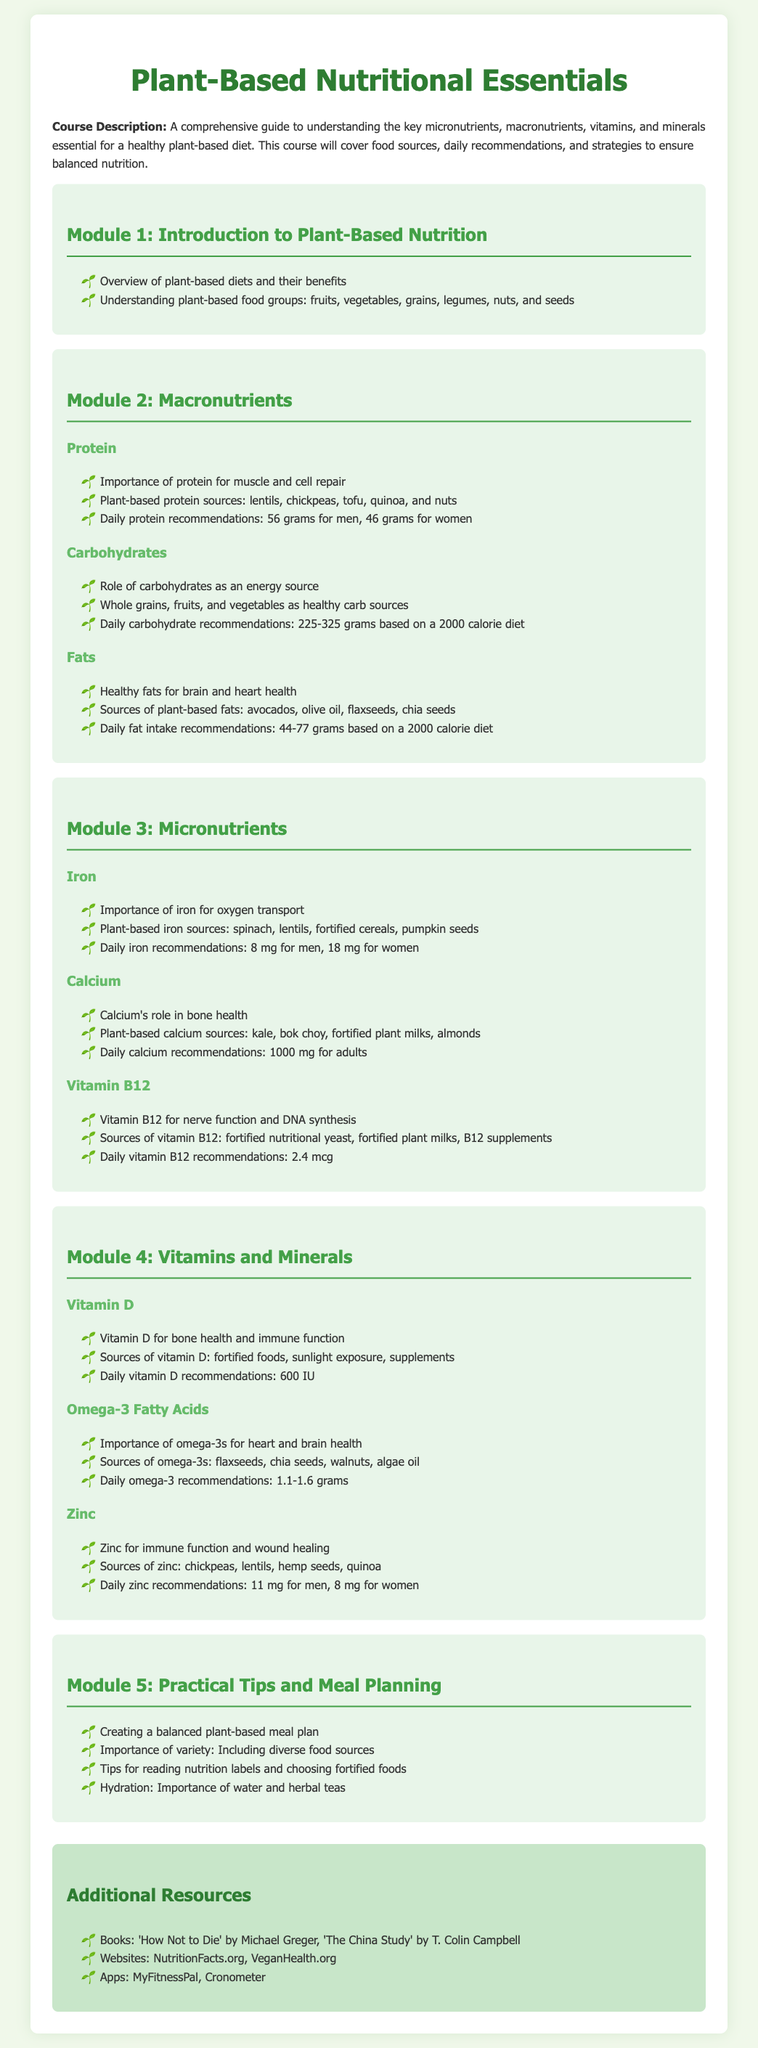What is the title of the course? The title of the course is mentioned at the top of the document.
Answer: Plant-Based Nutritional Essentials How many modules are there? The document lists the modules underlined by titles in the syllabus content.
Answer: Five What is the daily protein recommendation for men? The daily protein recommendation is specifically stated in the protein section of macronutrients.
Answer: 56 grams Which food source is high in omega-3 fatty acids? The document provides specific plant-based sources under the omega-3 fatty acids section.
Answer: Flaxseeds What is the role of calcium? The role of calcium is described in context to its importance in the micronutrients section.
Answer: Bone health What is one of the practical tips for meal planning? Practical tips for meal planning are listed in the last module of the syllabus.
Answer: Creating a balanced plant-based meal plan What is a recommended source of Vitamin B12? The sources for Vitamin B12 are provided in the relevant section under micronutrients.
Answer: Fortified nutritional yeast What is the daily iron recommendation for women? The daily iron recommendations are stated alongside the iron micronutrient section.
Answer: 18 mg 